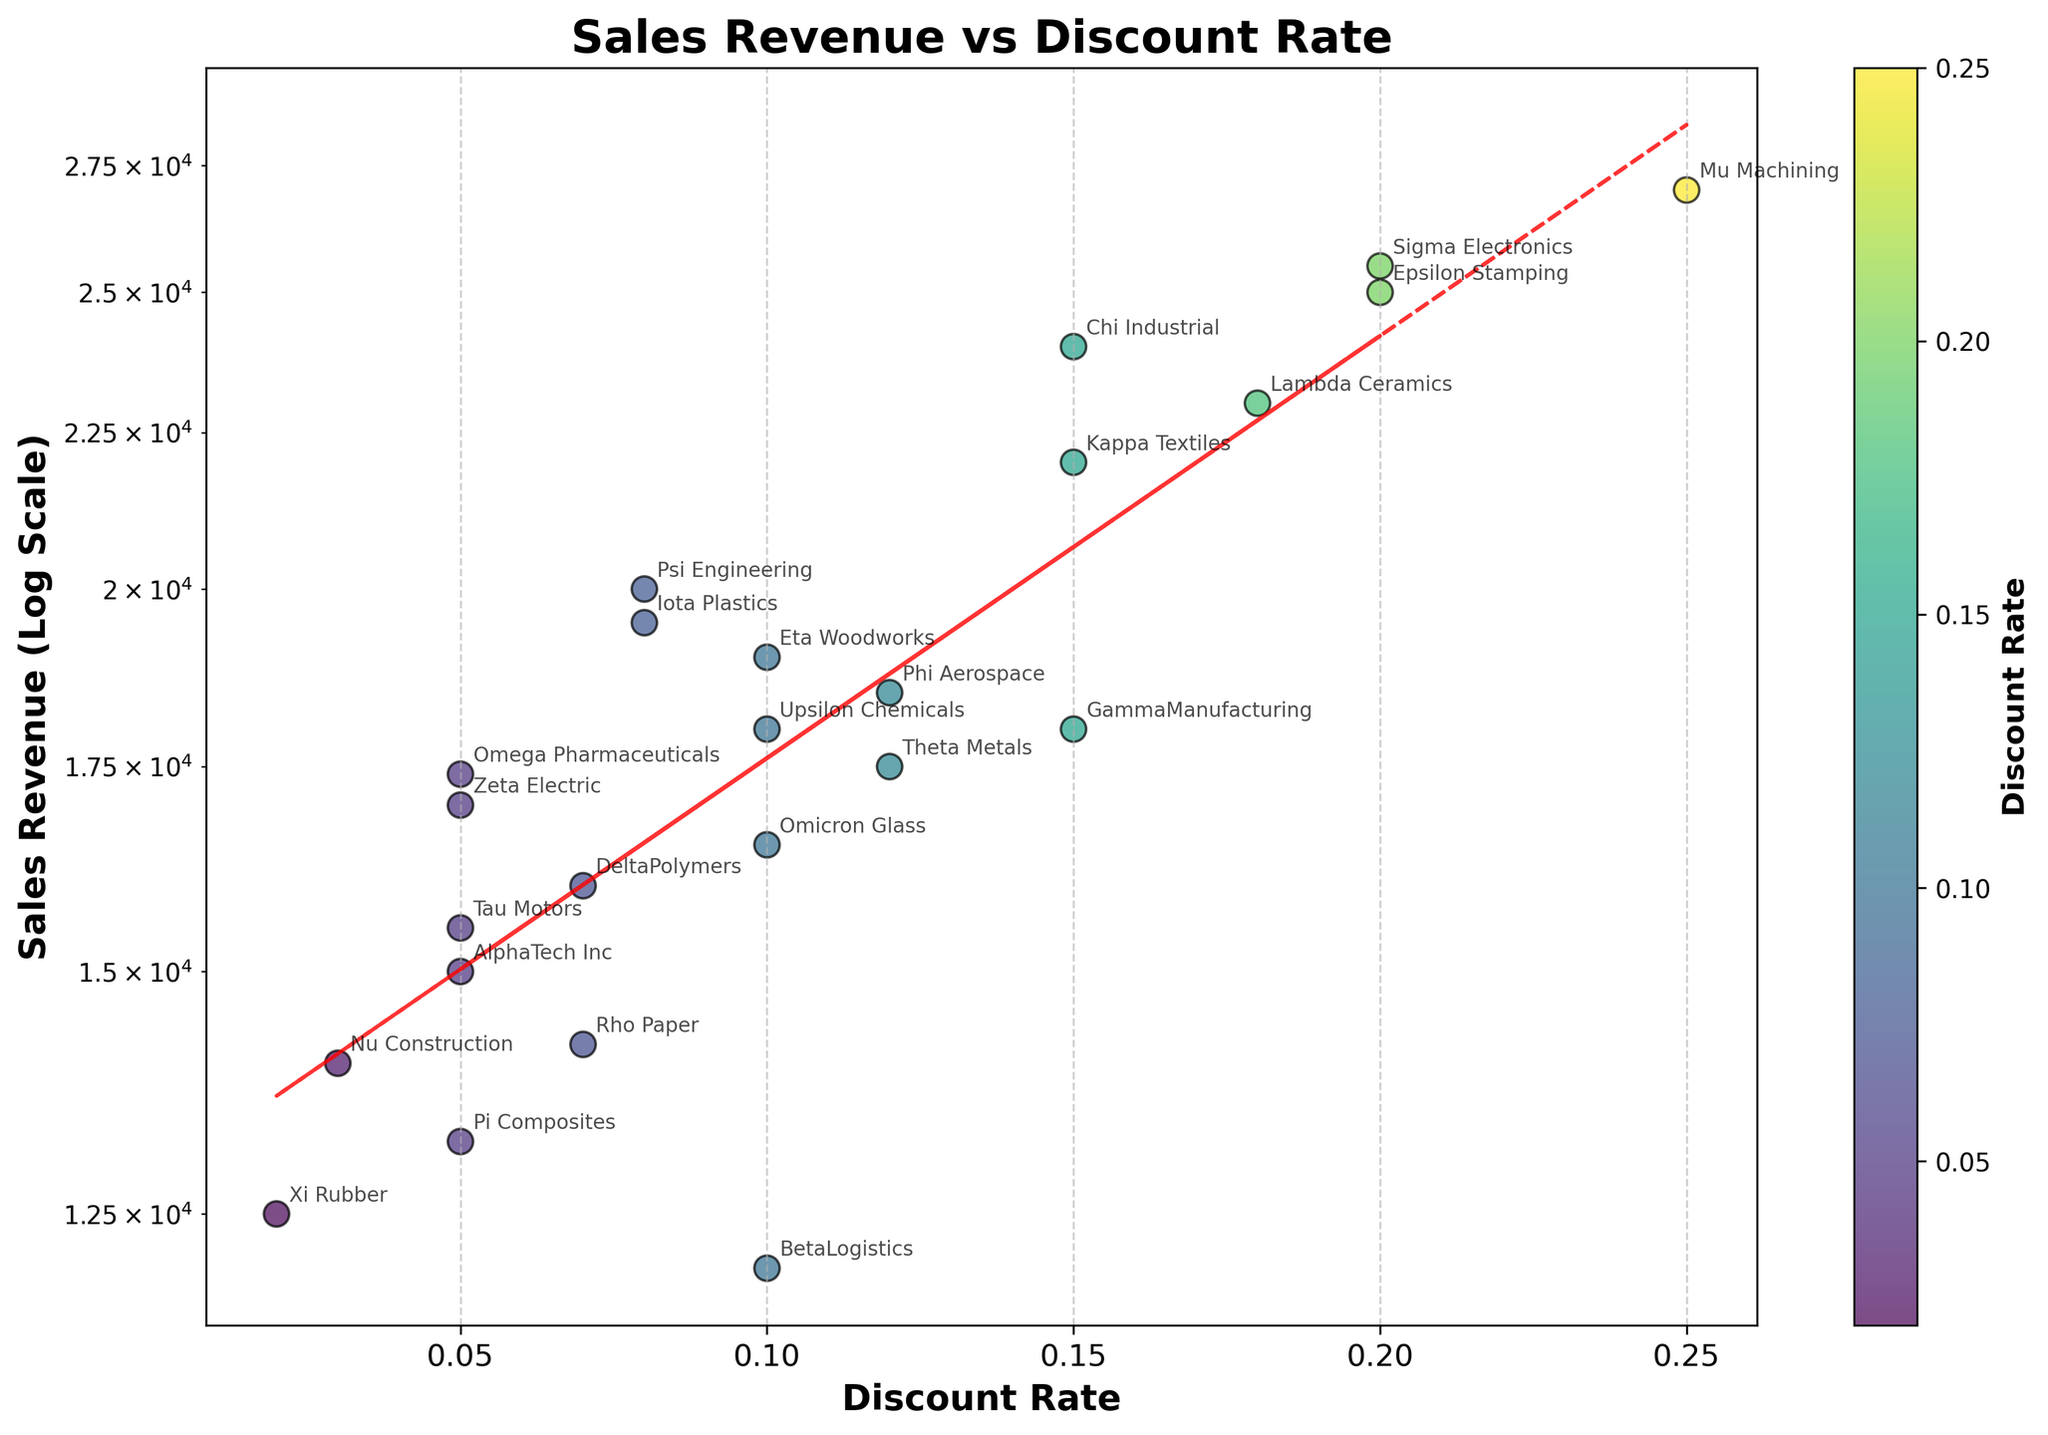How many data points are there in the scatter plot? The scatter plot represents the data for each company, and there are 24 companies listed in the dataset. Therefore, there are 24 data points on the scatter plot.
Answer: 24 Which company offered the highest discount rate, and what was their sales revenue? Mu Machining provided the highest discount rate at 0.25 and their sales revenue was 27,000, as indicated by their position on the plot.
Answer: Mu Machining, 27,000 Which two companies have nearly the same discount rate but different sales revenues? Companies Gamma Manufacturing and Kappa Textiles both have a discount rate of 0.15, but Gamma Manufacturing has a sales revenue of 18,000 and Kappa Textiles has a sales revenue of 22,000. This can be seen by locating these points on the plot.
Answer: Gamma Manufacturing and Kappa Textiles Is there a general trend in the relationship between discount rate and sales revenue? The plot includes a red dashed trend line, which suggests that as the discount rate increases, the sales revenue tends to increase. The trend line fits an exponential relationship due to the log scale y-axis.
Answer: Sales revenue tends to increase with a higher discount rate What is the difference in sales revenue between Epsilon Stamping and Chi Industrial, given they have different discount rates? Epsilon Stamping has a discount rate of 0.20 and a sales revenue of 25,000. Chi Industrial has a discount rate of 0.15 and a sales revenue of 24,000. The difference in sales revenue is 25,000 - 24,000.
Answer: 1,000 Which company with a discount rate of 0.10 has the highest sales revenue? Among the companies with a 0.10 discount rate, Eta Woodworks has the highest sales revenue of 19,000, as reflected in their plotted position on the scatter plot.
Answer: Eta Woodworks How does the sales revenue of companies with a 0.05 discount rate compare? The sales revenues for companies with a 0.05 discount rate are AlphaTech Inc (15,000), Zeta Electric (17,000), Pi Composites (13,200), Tau Motors (15,500), and Omega Pharmaceuticals (17,400). By comparing these values, we see Omega Pharmaceuticals has the highest sales revenue within this group.
Answer: Omega Pharmaceuticals Is there any company with a discount rate lower than 0.03, and what is their sales revenue? Xi Rubber provided the lowest discount rate of 0.02, and their sales revenue is 12,500, as indicated on the scatter plot.
Answer: Xi Rubber with 12,500 Which company has the closest sales revenue to 20,000, and what is its discount rate? Psi Engineering has a sales revenue of 20,000 and a discount rate of 0.08. This can be observed by finding the data point nearest to 20,000 on the y-axis.
Answer: Psi Engineering with a 0.08 discount rate 